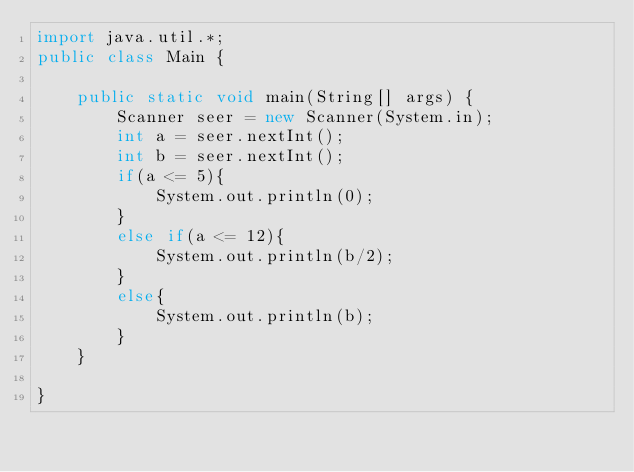<code> <loc_0><loc_0><loc_500><loc_500><_Java_>import java.util.*;
public class Main {

	public static void main(String[] args) {
		Scanner seer = new Scanner(System.in);
		int a = seer.nextInt();
		int b = seer.nextInt();
		if(a <= 5){
			System.out.println(0);
		}
		else if(a <= 12){
			System.out.println(b/2);
		}
		else{
			System.out.println(b);
		}
	}

}
</code> 